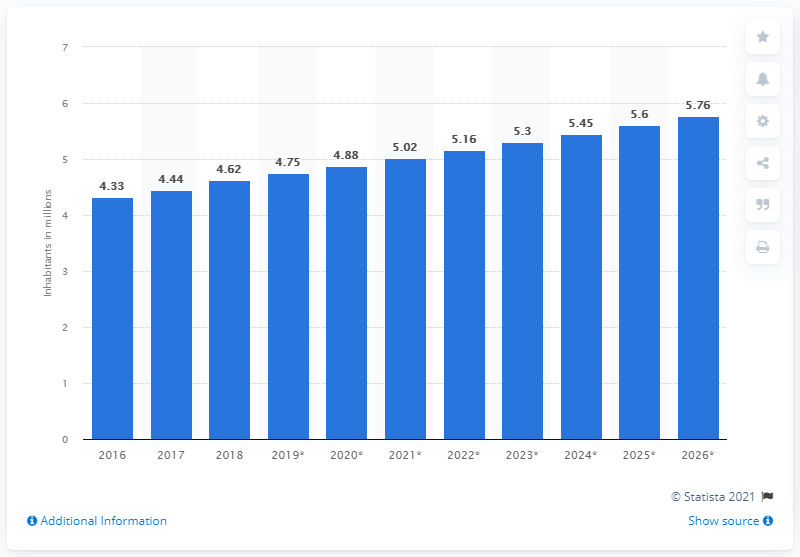What was Kuwait's population in 2018?
 4.62 